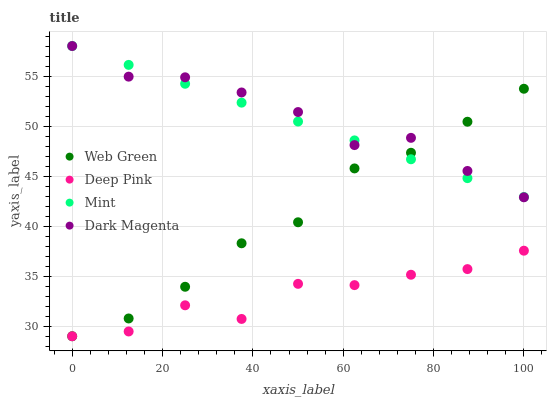Does Deep Pink have the minimum area under the curve?
Answer yes or no. Yes. Does Dark Magenta have the maximum area under the curve?
Answer yes or no. Yes. Does Mint have the minimum area under the curve?
Answer yes or no. No. Does Mint have the maximum area under the curve?
Answer yes or no. No. Is Mint the smoothest?
Answer yes or no. Yes. Is Deep Pink the roughest?
Answer yes or no. Yes. Is Dark Magenta the smoothest?
Answer yes or no. No. Is Dark Magenta the roughest?
Answer yes or no. No. Does Deep Pink have the lowest value?
Answer yes or no. Yes. Does Dark Magenta have the lowest value?
Answer yes or no. No. Does Dark Magenta have the highest value?
Answer yes or no. Yes. Does Web Green have the highest value?
Answer yes or no. No. Is Deep Pink less than Mint?
Answer yes or no. Yes. Is Dark Magenta greater than Deep Pink?
Answer yes or no. Yes. Does Web Green intersect Deep Pink?
Answer yes or no. Yes. Is Web Green less than Deep Pink?
Answer yes or no. No. Is Web Green greater than Deep Pink?
Answer yes or no. No. Does Deep Pink intersect Mint?
Answer yes or no. No. 